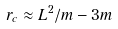<formula> <loc_0><loc_0><loc_500><loc_500>r _ { c } \approx L ^ { 2 } / m - 3 m</formula> 